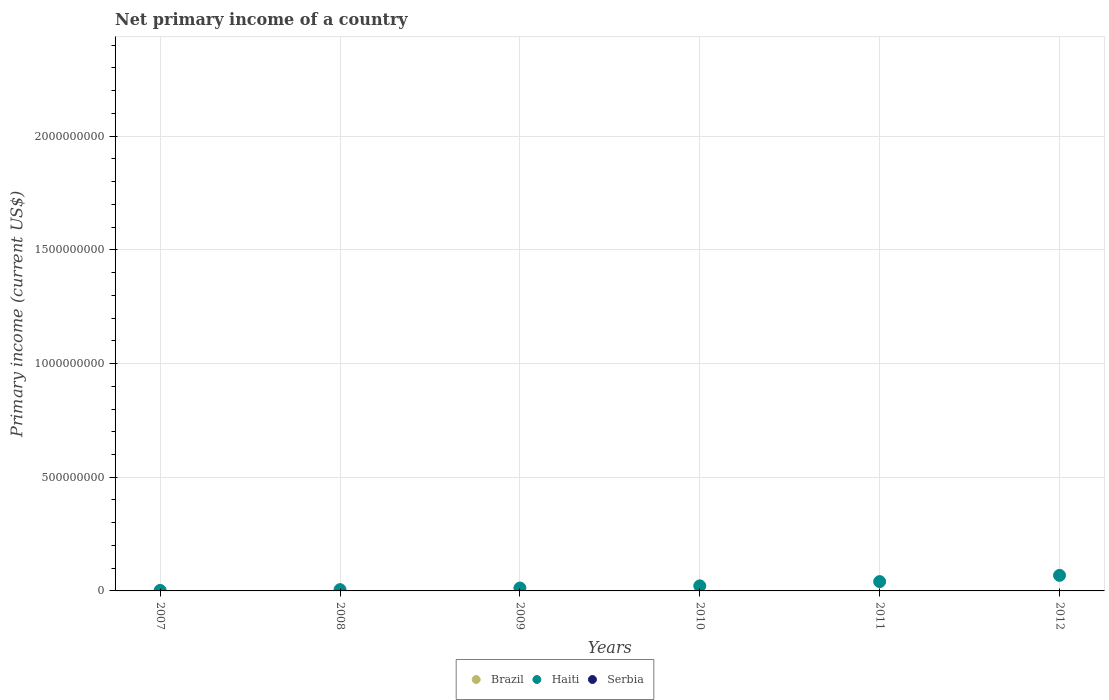Is the number of dotlines equal to the number of legend labels?
Your answer should be compact. No. What is the primary income in Haiti in 2008?
Ensure brevity in your answer.  5.55e+06. In which year was the primary income in Haiti maximum?
Provide a short and direct response. 2012. What is the difference between the primary income in Haiti in 2009 and that in 2010?
Keep it short and to the point. -9.49e+06. What is the difference between the primary income in Brazil in 2012 and the primary income in Haiti in 2007?
Ensure brevity in your answer.  -2.21e+06. What is the ratio of the primary income in Haiti in 2007 to that in 2009?
Ensure brevity in your answer.  0.17. Is the primary income in Haiti in 2009 less than that in 2011?
Provide a succinct answer. Yes. What is the difference between the highest and the second highest primary income in Haiti?
Give a very brief answer. 2.75e+07. In how many years, is the primary income in Serbia greater than the average primary income in Serbia taken over all years?
Your answer should be compact. 0. Is the sum of the primary income in Haiti in 2008 and 2010 greater than the maximum primary income in Serbia across all years?
Give a very brief answer. Yes. Is the primary income in Brazil strictly less than the primary income in Haiti over the years?
Offer a very short reply. Yes. How many dotlines are there?
Ensure brevity in your answer.  1. What is the difference between two consecutive major ticks on the Y-axis?
Provide a succinct answer. 5.00e+08. Are the values on the major ticks of Y-axis written in scientific E-notation?
Keep it short and to the point. No. Does the graph contain any zero values?
Your response must be concise. Yes. Does the graph contain grids?
Keep it short and to the point. Yes. Where does the legend appear in the graph?
Offer a very short reply. Bottom center. How many legend labels are there?
Your answer should be compact. 3. What is the title of the graph?
Provide a succinct answer. Net primary income of a country. What is the label or title of the X-axis?
Your answer should be compact. Years. What is the label or title of the Y-axis?
Provide a succinct answer. Primary income (current US$). What is the Primary income (current US$) of Haiti in 2007?
Make the answer very short. 2.21e+06. What is the Primary income (current US$) of Brazil in 2008?
Give a very brief answer. 0. What is the Primary income (current US$) in Haiti in 2008?
Give a very brief answer. 5.55e+06. What is the Primary income (current US$) in Brazil in 2009?
Your answer should be very brief. 0. What is the Primary income (current US$) in Haiti in 2009?
Your response must be concise. 1.28e+07. What is the Primary income (current US$) of Serbia in 2009?
Make the answer very short. 0. What is the Primary income (current US$) in Haiti in 2010?
Ensure brevity in your answer.  2.23e+07. What is the Primary income (current US$) of Serbia in 2010?
Your response must be concise. 0. What is the Primary income (current US$) in Brazil in 2011?
Provide a short and direct response. 0. What is the Primary income (current US$) of Haiti in 2011?
Your answer should be very brief. 4.10e+07. What is the Primary income (current US$) of Brazil in 2012?
Ensure brevity in your answer.  0. What is the Primary income (current US$) of Haiti in 2012?
Offer a terse response. 6.84e+07. What is the Primary income (current US$) of Serbia in 2012?
Your answer should be compact. 0. Across all years, what is the maximum Primary income (current US$) in Haiti?
Your answer should be very brief. 6.84e+07. Across all years, what is the minimum Primary income (current US$) in Haiti?
Offer a terse response. 2.21e+06. What is the total Primary income (current US$) in Brazil in the graph?
Your answer should be very brief. 0. What is the total Primary income (current US$) in Haiti in the graph?
Give a very brief answer. 1.52e+08. What is the total Primary income (current US$) of Serbia in the graph?
Your answer should be compact. 0. What is the difference between the Primary income (current US$) in Haiti in 2007 and that in 2008?
Ensure brevity in your answer.  -3.34e+06. What is the difference between the Primary income (current US$) in Haiti in 2007 and that in 2009?
Your answer should be very brief. -1.06e+07. What is the difference between the Primary income (current US$) of Haiti in 2007 and that in 2010?
Your answer should be compact. -2.01e+07. What is the difference between the Primary income (current US$) in Haiti in 2007 and that in 2011?
Your response must be concise. -3.88e+07. What is the difference between the Primary income (current US$) of Haiti in 2007 and that in 2012?
Your answer should be compact. -6.62e+07. What is the difference between the Primary income (current US$) in Haiti in 2008 and that in 2009?
Your answer should be very brief. -7.25e+06. What is the difference between the Primary income (current US$) of Haiti in 2008 and that in 2010?
Keep it short and to the point. -1.67e+07. What is the difference between the Primary income (current US$) of Haiti in 2008 and that in 2011?
Provide a short and direct response. -3.55e+07. What is the difference between the Primary income (current US$) in Haiti in 2008 and that in 2012?
Your answer should be compact. -6.29e+07. What is the difference between the Primary income (current US$) in Haiti in 2009 and that in 2010?
Give a very brief answer. -9.49e+06. What is the difference between the Primary income (current US$) in Haiti in 2009 and that in 2011?
Your response must be concise. -2.82e+07. What is the difference between the Primary income (current US$) in Haiti in 2009 and that in 2012?
Offer a terse response. -5.56e+07. What is the difference between the Primary income (current US$) in Haiti in 2010 and that in 2011?
Keep it short and to the point. -1.87e+07. What is the difference between the Primary income (current US$) in Haiti in 2010 and that in 2012?
Keep it short and to the point. -4.62e+07. What is the difference between the Primary income (current US$) of Haiti in 2011 and that in 2012?
Ensure brevity in your answer.  -2.75e+07. What is the average Primary income (current US$) in Haiti per year?
Your answer should be compact. 2.54e+07. What is the average Primary income (current US$) in Serbia per year?
Ensure brevity in your answer.  0. What is the ratio of the Primary income (current US$) in Haiti in 2007 to that in 2008?
Make the answer very short. 0.4. What is the ratio of the Primary income (current US$) in Haiti in 2007 to that in 2009?
Ensure brevity in your answer.  0.17. What is the ratio of the Primary income (current US$) of Haiti in 2007 to that in 2010?
Make the answer very short. 0.1. What is the ratio of the Primary income (current US$) in Haiti in 2007 to that in 2011?
Offer a very short reply. 0.05. What is the ratio of the Primary income (current US$) in Haiti in 2007 to that in 2012?
Give a very brief answer. 0.03. What is the ratio of the Primary income (current US$) of Haiti in 2008 to that in 2009?
Your answer should be compact. 0.43. What is the ratio of the Primary income (current US$) of Haiti in 2008 to that in 2010?
Ensure brevity in your answer.  0.25. What is the ratio of the Primary income (current US$) in Haiti in 2008 to that in 2011?
Provide a succinct answer. 0.14. What is the ratio of the Primary income (current US$) in Haiti in 2008 to that in 2012?
Make the answer very short. 0.08. What is the ratio of the Primary income (current US$) of Haiti in 2009 to that in 2010?
Your answer should be compact. 0.57. What is the ratio of the Primary income (current US$) in Haiti in 2009 to that in 2011?
Keep it short and to the point. 0.31. What is the ratio of the Primary income (current US$) of Haiti in 2009 to that in 2012?
Your response must be concise. 0.19. What is the ratio of the Primary income (current US$) of Haiti in 2010 to that in 2011?
Your answer should be compact. 0.54. What is the ratio of the Primary income (current US$) in Haiti in 2010 to that in 2012?
Keep it short and to the point. 0.33. What is the ratio of the Primary income (current US$) in Haiti in 2011 to that in 2012?
Your response must be concise. 0.6. What is the difference between the highest and the second highest Primary income (current US$) of Haiti?
Offer a terse response. 2.75e+07. What is the difference between the highest and the lowest Primary income (current US$) of Haiti?
Your response must be concise. 6.62e+07. 